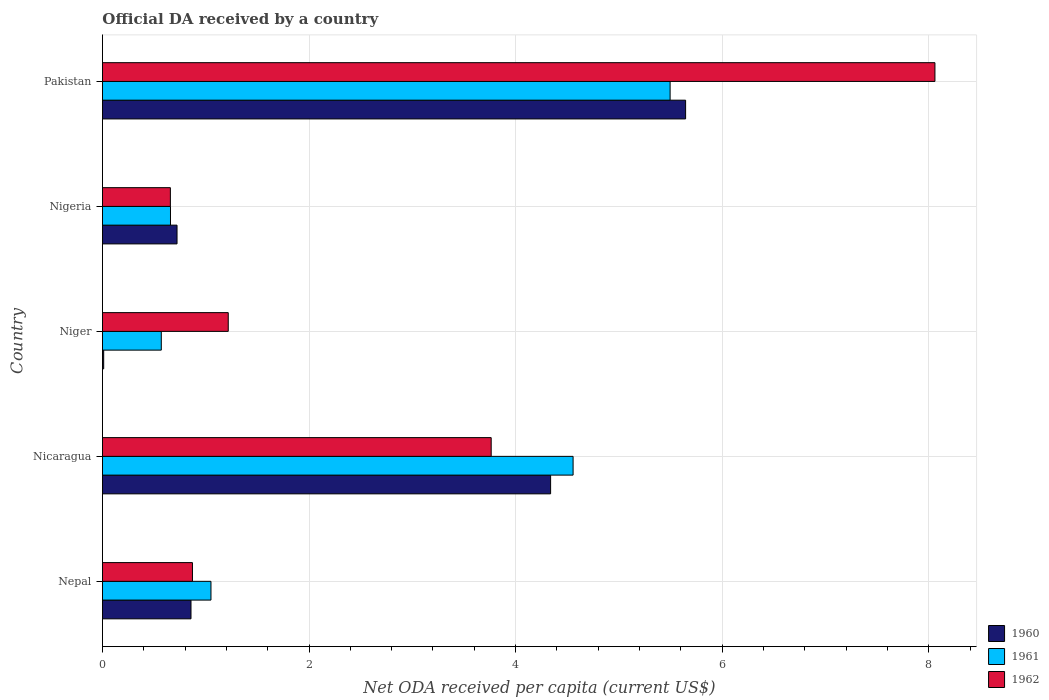How many different coloured bars are there?
Make the answer very short. 3. How many groups of bars are there?
Give a very brief answer. 5. How many bars are there on the 2nd tick from the top?
Your response must be concise. 3. What is the ODA received in in 1960 in Nicaragua?
Offer a terse response. 4.34. Across all countries, what is the maximum ODA received in in 1962?
Make the answer very short. 8.06. Across all countries, what is the minimum ODA received in in 1960?
Your answer should be very brief. 0.01. In which country was the ODA received in in 1961 minimum?
Your answer should be compact. Niger. What is the total ODA received in in 1960 in the graph?
Give a very brief answer. 11.58. What is the difference between the ODA received in in 1960 in Nepal and that in Pakistan?
Offer a terse response. -4.79. What is the difference between the ODA received in in 1962 in Nepal and the ODA received in in 1961 in Niger?
Offer a terse response. 0.3. What is the average ODA received in in 1960 per country?
Offer a terse response. 2.32. What is the difference between the ODA received in in 1962 and ODA received in in 1961 in Pakistan?
Provide a succinct answer. 2.56. What is the ratio of the ODA received in in 1961 in Nepal to that in Pakistan?
Provide a short and direct response. 0.19. Is the difference between the ODA received in in 1962 in Nicaragua and Niger greater than the difference between the ODA received in in 1961 in Nicaragua and Niger?
Provide a short and direct response. No. What is the difference between the highest and the second highest ODA received in in 1962?
Ensure brevity in your answer.  4.3. What is the difference between the highest and the lowest ODA received in in 1960?
Provide a short and direct response. 5.63. Is the sum of the ODA received in in 1960 in Niger and Nigeria greater than the maximum ODA received in in 1962 across all countries?
Give a very brief answer. No. What does the 1st bar from the bottom in Nigeria represents?
Make the answer very short. 1960. Is it the case that in every country, the sum of the ODA received in in 1961 and ODA received in in 1960 is greater than the ODA received in in 1962?
Keep it short and to the point. No. Are all the bars in the graph horizontal?
Provide a succinct answer. Yes. What is the difference between two consecutive major ticks on the X-axis?
Keep it short and to the point. 2. Are the values on the major ticks of X-axis written in scientific E-notation?
Keep it short and to the point. No. Where does the legend appear in the graph?
Make the answer very short. Bottom right. How are the legend labels stacked?
Your answer should be compact. Vertical. What is the title of the graph?
Keep it short and to the point. Official DA received by a country. What is the label or title of the X-axis?
Your answer should be very brief. Net ODA received per capita (current US$). What is the label or title of the Y-axis?
Offer a very short reply. Country. What is the Net ODA received per capita (current US$) in 1960 in Nepal?
Keep it short and to the point. 0.86. What is the Net ODA received per capita (current US$) of 1961 in Nepal?
Make the answer very short. 1.05. What is the Net ODA received per capita (current US$) of 1962 in Nepal?
Give a very brief answer. 0.87. What is the Net ODA received per capita (current US$) in 1960 in Nicaragua?
Your response must be concise. 4.34. What is the Net ODA received per capita (current US$) of 1961 in Nicaragua?
Your answer should be compact. 4.56. What is the Net ODA received per capita (current US$) in 1962 in Nicaragua?
Your answer should be very brief. 3.76. What is the Net ODA received per capita (current US$) in 1960 in Niger?
Offer a very short reply. 0.01. What is the Net ODA received per capita (current US$) of 1961 in Niger?
Offer a very short reply. 0.57. What is the Net ODA received per capita (current US$) of 1962 in Niger?
Offer a terse response. 1.22. What is the Net ODA received per capita (current US$) of 1960 in Nigeria?
Your answer should be compact. 0.72. What is the Net ODA received per capita (current US$) of 1961 in Nigeria?
Your answer should be very brief. 0.66. What is the Net ODA received per capita (current US$) in 1962 in Nigeria?
Give a very brief answer. 0.66. What is the Net ODA received per capita (current US$) in 1960 in Pakistan?
Keep it short and to the point. 5.65. What is the Net ODA received per capita (current US$) of 1961 in Pakistan?
Provide a short and direct response. 5.5. What is the Net ODA received per capita (current US$) in 1962 in Pakistan?
Ensure brevity in your answer.  8.06. Across all countries, what is the maximum Net ODA received per capita (current US$) of 1960?
Offer a terse response. 5.65. Across all countries, what is the maximum Net ODA received per capita (current US$) of 1961?
Your answer should be very brief. 5.5. Across all countries, what is the maximum Net ODA received per capita (current US$) of 1962?
Keep it short and to the point. 8.06. Across all countries, what is the minimum Net ODA received per capita (current US$) in 1960?
Provide a short and direct response. 0.01. Across all countries, what is the minimum Net ODA received per capita (current US$) in 1961?
Provide a succinct answer. 0.57. Across all countries, what is the minimum Net ODA received per capita (current US$) in 1962?
Give a very brief answer. 0.66. What is the total Net ODA received per capita (current US$) of 1960 in the graph?
Ensure brevity in your answer.  11.58. What is the total Net ODA received per capita (current US$) of 1961 in the graph?
Make the answer very short. 12.33. What is the total Net ODA received per capita (current US$) in 1962 in the graph?
Offer a terse response. 14.57. What is the difference between the Net ODA received per capita (current US$) of 1960 in Nepal and that in Nicaragua?
Your response must be concise. -3.48. What is the difference between the Net ODA received per capita (current US$) of 1961 in Nepal and that in Nicaragua?
Provide a succinct answer. -3.51. What is the difference between the Net ODA received per capita (current US$) of 1962 in Nepal and that in Nicaragua?
Offer a very short reply. -2.89. What is the difference between the Net ODA received per capita (current US$) of 1960 in Nepal and that in Niger?
Offer a terse response. 0.85. What is the difference between the Net ODA received per capita (current US$) in 1961 in Nepal and that in Niger?
Ensure brevity in your answer.  0.48. What is the difference between the Net ODA received per capita (current US$) of 1962 in Nepal and that in Niger?
Offer a very short reply. -0.35. What is the difference between the Net ODA received per capita (current US$) in 1960 in Nepal and that in Nigeria?
Give a very brief answer. 0.14. What is the difference between the Net ODA received per capita (current US$) in 1961 in Nepal and that in Nigeria?
Provide a succinct answer. 0.39. What is the difference between the Net ODA received per capita (current US$) of 1962 in Nepal and that in Nigeria?
Offer a very short reply. 0.21. What is the difference between the Net ODA received per capita (current US$) in 1960 in Nepal and that in Pakistan?
Keep it short and to the point. -4.79. What is the difference between the Net ODA received per capita (current US$) of 1961 in Nepal and that in Pakistan?
Offer a terse response. -4.45. What is the difference between the Net ODA received per capita (current US$) of 1962 in Nepal and that in Pakistan?
Provide a succinct answer. -7.19. What is the difference between the Net ODA received per capita (current US$) of 1960 in Nicaragua and that in Niger?
Offer a very short reply. 4.33. What is the difference between the Net ODA received per capita (current US$) in 1961 in Nicaragua and that in Niger?
Keep it short and to the point. 3.99. What is the difference between the Net ODA received per capita (current US$) of 1962 in Nicaragua and that in Niger?
Your answer should be compact. 2.55. What is the difference between the Net ODA received per capita (current US$) in 1960 in Nicaragua and that in Nigeria?
Your answer should be very brief. 3.62. What is the difference between the Net ODA received per capita (current US$) in 1961 in Nicaragua and that in Nigeria?
Keep it short and to the point. 3.9. What is the difference between the Net ODA received per capita (current US$) of 1962 in Nicaragua and that in Nigeria?
Provide a succinct answer. 3.11. What is the difference between the Net ODA received per capita (current US$) in 1960 in Nicaragua and that in Pakistan?
Make the answer very short. -1.31. What is the difference between the Net ODA received per capita (current US$) in 1961 in Nicaragua and that in Pakistan?
Make the answer very short. -0.94. What is the difference between the Net ODA received per capita (current US$) of 1962 in Nicaragua and that in Pakistan?
Ensure brevity in your answer.  -4.3. What is the difference between the Net ODA received per capita (current US$) in 1960 in Niger and that in Nigeria?
Provide a succinct answer. -0.71. What is the difference between the Net ODA received per capita (current US$) of 1961 in Niger and that in Nigeria?
Give a very brief answer. -0.09. What is the difference between the Net ODA received per capita (current US$) in 1962 in Niger and that in Nigeria?
Ensure brevity in your answer.  0.56. What is the difference between the Net ODA received per capita (current US$) in 1960 in Niger and that in Pakistan?
Give a very brief answer. -5.63. What is the difference between the Net ODA received per capita (current US$) of 1961 in Niger and that in Pakistan?
Keep it short and to the point. -4.93. What is the difference between the Net ODA received per capita (current US$) of 1962 in Niger and that in Pakistan?
Provide a succinct answer. -6.84. What is the difference between the Net ODA received per capita (current US$) in 1960 in Nigeria and that in Pakistan?
Keep it short and to the point. -4.92. What is the difference between the Net ODA received per capita (current US$) of 1961 in Nigeria and that in Pakistan?
Ensure brevity in your answer.  -4.84. What is the difference between the Net ODA received per capita (current US$) in 1962 in Nigeria and that in Pakistan?
Give a very brief answer. -7.4. What is the difference between the Net ODA received per capita (current US$) of 1960 in Nepal and the Net ODA received per capita (current US$) of 1961 in Nicaragua?
Give a very brief answer. -3.7. What is the difference between the Net ODA received per capita (current US$) of 1960 in Nepal and the Net ODA received per capita (current US$) of 1962 in Nicaragua?
Provide a succinct answer. -2.91. What is the difference between the Net ODA received per capita (current US$) in 1961 in Nepal and the Net ODA received per capita (current US$) in 1962 in Nicaragua?
Provide a succinct answer. -2.71. What is the difference between the Net ODA received per capita (current US$) in 1960 in Nepal and the Net ODA received per capita (current US$) in 1961 in Niger?
Keep it short and to the point. 0.29. What is the difference between the Net ODA received per capita (current US$) of 1960 in Nepal and the Net ODA received per capita (current US$) of 1962 in Niger?
Your answer should be compact. -0.36. What is the difference between the Net ODA received per capita (current US$) in 1961 in Nepal and the Net ODA received per capita (current US$) in 1962 in Niger?
Give a very brief answer. -0.17. What is the difference between the Net ODA received per capita (current US$) of 1960 in Nepal and the Net ODA received per capita (current US$) of 1961 in Nigeria?
Provide a short and direct response. 0.2. What is the difference between the Net ODA received per capita (current US$) in 1960 in Nepal and the Net ODA received per capita (current US$) in 1962 in Nigeria?
Provide a succinct answer. 0.2. What is the difference between the Net ODA received per capita (current US$) of 1961 in Nepal and the Net ODA received per capita (current US$) of 1962 in Nigeria?
Offer a terse response. 0.39. What is the difference between the Net ODA received per capita (current US$) in 1960 in Nepal and the Net ODA received per capita (current US$) in 1961 in Pakistan?
Ensure brevity in your answer.  -4.64. What is the difference between the Net ODA received per capita (current US$) in 1960 in Nepal and the Net ODA received per capita (current US$) in 1962 in Pakistan?
Your answer should be very brief. -7.2. What is the difference between the Net ODA received per capita (current US$) of 1961 in Nepal and the Net ODA received per capita (current US$) of 1962 in Pakistan?
Offer a very short reply. -7.01. What is the difference between the Net ODA received per capita (current US$) in 1960 in Nicaragua and the Net ODA received per capita (current US$) in 1961 in Niger?
Keep it short and to the point. 3.77. What is the difference between the Net ODA received per capita (current US$) in 1960 in Nicaragua and the Net ODA received per capita (current US$) in 1962 in Niger?
Ensure brevity in your answer.  3.12. What is the difference between the Net ODA received per capita (current US$) of 1961 in Nicaragua and the Net ODA received per capita (current US$) of 1962 in Niger?
Keep it short and to the point. 3.34. What is the difference between the Net ODA received per capita (current US$) of 1960 in Nicaragua and the Net ODA received per capita (current US$) of 1961 in Nigeria?
Make the answer very short. 3.68. What is the difference between the Net ODA received per capita (current US$) of 1960 in Nicaragua and the Net ODA received per capita (current US$) of 1962 in Nigeria?
Ensure brevity in your answer.  3.68. What is the difference between the Net ODA received per capita (current US$) of 1961 in Nicaragua and the Net ODA received per capita (current US$) of 1962 in Nigeria?
Provide a short and direct response. 3.9. What is the difference between the Net ODA received per capita (current US$) in 1960 in Nicaragua and the Net ODA received per capita (current US$) in 1961 in Pakistan?
Ensure brevity in your answer.  -1.16. What is the difference between the Net ODA received per capita (current US$) in 1960 in Nicaragua and the Net ODA received per capita (current US$) in 1962 in Pakistan?
Your answer should be compact. -3.72. What is the difference between the Net ODA received per capita (current US$) in 1961 in Nicaragua and the Net ODA received per capita (current US$) in 1962 in Pakistan?
Provide a short and direct response. -3.5. What is the difference between the Net ODA received per capita (current US$) in 1960 in Niger and the Net ODA received per capita (current US$) in 1961 in Nigeria?
Keep it short and to the point. -0.65. What is the difference between the Net ODA received per capita (current US$) in 1960 in Niger and the Net ODA received per capita (current US$) in 1962 in Nigeria?
Ensure brevity in your answer.  -0.65. What is the difference between the Net ODA received per capita (current US$) in 1961 in Niger and the Net ODA received per capita (current US$) in 1962 in Nigeria?
Provide a succinct answer. -0.09. What is the difference between the Net ODA received per capita (current US$) in 1960 in Niger and the Net ODA received per capita (current US$) in 1961 in Pakistan?
Ensure brevity in your answer.  -5.48. What is the difference between the Net ODA received per capita (current US$) in 1960 in Niger and the Net ODA received per capita (current US$) in 1962 in Pakistan?
Your answer should be very brief. -8.05. What is the difference between the Net ODA received per capita (current US$) of 1961 in Niger and the Net ODA received per capita (current US$) of 1962 in Pakistan?
Your answer should be very brief. -7.49. What is the difference between the Net ODA received per capita (current US$) of 1960 in Nigeria and the Net ODA received per capita (current US$) of 1961 in Pakistan?
Your answer should be compact. -4.77. What is the difference between the Net ODA received per capita (current US$) of 1960 in Nigeria and the Net ODA received per capita (current US$) of 1962 in Pakistan?
Your answer should be very brief. -7.34. What is the difference between the Net ODA received per capita (current US$) of 1961 in Nigeria and the Net ODA received per capita (current US$) of 1962 in Pakistan?
Give a very brief answer. -7.4. What is the average Net ODA received per capita (current US$) of 1960 per country?
Provide a succinct answer. 2.32. What is the average Net ODA received per capita (current US$) in 1961 per country?
Your response must be concise. 2.47. What is the average Net ODA received per capita (current US$) in 1962 per country?
Your answer should be compact. 2.91. What is the difference between the Net ODA received per capita (current US$) in 1960 and Net ODA received per capita (current US$) in 1961 in Nepal?
Offer a very short reply. -0.19. What is the difference between the Net ODA received per capita (current US$) of 1960 and Net ODA received per capita (current US$) of 1962 in Nepal?
Make the answer very short. -0.01. What is the difference between the Net ODA received per capita (current US$) in 1961 and Net ODA received per capita (current US$) in 1962 in Nepal?
Offer a very short reply. 0.18. What is the difference between the Net ODA received per capita (current US$) of 1960 and Net ODA received per capita (current US$) of 1961 in Nicaragua?
Offer a terse response. -0.22. What is the difference between the Net ODA received per capita (current US$) of 1960 and Net ODA received per capita (current US$) of 1962 in Nicaragua?
Keep it short and to the point. 0.58. What is the difference between the Net ODA received per capita (current US$) in 1961 and Net ODA received per capita (current US$) in 1962 in Nicaragua?
Ensure brevity in your answer.  0.79. What is the difference between the Net ODA received per capita (current US$) of 1960 and Net ODA received per capita (current US$) of 1961 in Niger?
Provide a short and direct response. -0.56. What is the difference between the Net ODA received per capita (current US$) of 1960 and Net ODA received per capita (current US$) of 1962 in Niger?
Keep it short and to the point. -1.21. What is the difference between the Net ODA received per capita (current US$) of 1961 and Net ODA received per capita (current US$) of 1962 in Niger?
Your answer should be very brief. -0.65. What is the difference between the Net ODA received per capita (current US$) of 1960 and Net ODA received per capita (current US$) of 1961 in Nigeria?
Provide a succinct answer. 0.06. What is the difference between the Net ODA received per capita (current US$) of 1960 and Net ODA received per capita (current US$) of 1962 in Nigeria?
Offer a terse response. 0.06. What is the difference between the Net ODA received per capita (current US$) in 1961 and Net ODA received per capita (current US$) in 1962 in Nigeria?
Your response must be concise. 0. What is the difference between the Net ODA received per capita (current US$) of 1960 and Net ODA received per capita (current US$) of 1961 in Pakistan?
Provide a short and direct response. 0.15. What is the difference between the Net ODA received per capita (current US$) of 1960 and Net ODA received per capita (current US$) of 1962 in Pakistan?
Keep it short and to the point. -2.41. What is the difference between the Net ODA received per capita (current US$) of 1961 and Net ODA received per capita (current US$) of 1962 in Pakistan?
Give a very brief answer. -2.56. What is the ratio of the Net ODA received per capita (current US$) in 1960 in Nepal to that in Nicaragua?
Give a very brief answer. 0.2. What is the ratio of the Net ODA received per capita (current US$) in 1961 in Nepal to that in Nicaragua?
Keep it short and to the point. 0.23. What is the ratio of the Net ODA received per capita (current US$) in 1962 in Nepal to that in Nicaragua?
Make the answer very short. 0.23. What is the ratio of the Net ODA received per capita (current US$) in 1960 in Nepal to that in Niger?
Your answer should be compact. 72.75. What is the ratio of the Net ODA received per capita (current US$) in 1961 in Nepal to that in Niger?
Ensure brevity in your answer.  1.84. What is the ratio of the Net ODA received per capita (current US$) of 1962 in Nepal to that in Niger?
Offer a terse response. 0.72. What is the ratio of the Net ODA received per capita (current US$) of 1960 in Nepal to that in Nigeria?
Provide a short and direct response. 1.19. What is the ratio of the Net ODA received per capita (current US$) in 1961 in Nepal to that in Nigeria?
Ensure brevity in your answer.  1.59. What is the ratio of the Net ODA received per capita (current US$) of 1962 in Nepal to that in Nigeria?
Your answer should be compact. 1.32. What is the ratio of the Net ODA received per capita (current US$) of 1960 in Nepal to that in Pakistan?
Ensure brevity in your answer.  0.15. What is the ratio of the Net ODA received per capita (current US$) of 1961 in Nepal to that in Pakistan?
Your answer should be compact. 0.19. What is the ratio of the Net ODA received per capita (current US$) in 1962 in Nepal to that in Pakistan?
Keep it short and to the point. 0.11. What is the ratio of the Net ODA received per capita (current US$) of 1960 in Nicaragua to that in Niger?
Give a very brief answer. 368.28. What is the ratio of the Net ODA received per capita (current US$) of 1961 in Nicaragua to that in Niger?
Offer a very short reply. 8. What is the ratio of the Net ODA received per capita (current US$) in 1962 in Nicaragua to that in Niger?
Your answer should be compact. 3.09. What is the ratio of the Net ODA received per capita (current US$) in 1960 in Nicaragua to that in Nigeria?
Give a very brief answer. 6.01. What is the ratio of the Net ODA received per capita (current US$) in 1961 in Nicaragua to that in Nigeria?
Offer a very short reply. 6.92. What is the ratio of the Net ODA received per capita (current US$) of 1962 in Nicaragua to that in Nigeria?
Keep it short and to the point. 5.72. What is the ratio of the Net ODA received per capita (current US$) of 1960 in Nicaragua to that in Pakistan?
Your answer should be compact. 0.77. What is the ratio of the Net ODA received per capita (current US$) of 1961 in Nicaragua to that in Pakistan?
Keep it short and to the point. 0.83. What is the ratio of the Net ODA received per capita (current US$) in 1962 in Nicaragua to that in Pakistan?
Provide a short and direct response. 0.47. What is the ratio of the Net ODA received per capita (current US$) in 1960 in Niger to that in Nigeria?
Make the answer very short. 0.02. What is the ratio of the Net ODA received per capita (current US$) in 1961 in Niger to that in Nigeria?
Provide a short and direct response. 0.86. What is the ratio of the Net ODA received per capita (current US$) of 1962 in Niger to that in Nigeria?
Make the answer very short. 1.85. What is the ratio of the Net ODA received per capita (current US$) in 1960 in Niger to that in Pakistan?
Provide a short and direct response. 0. What is the ratio of the Net ODA received per capita (current US$) of 1961 in Niger to that in Pakistan?
Offer a very short reply. 0.1. What is the ratio of the Net ODA received per capita (current US$) of 1962 in Niger to that in Pakistan?
Give a very brief answer. 0.15. What is the ratio of the Net ODA received per capita (current US$) in 1960 in Nigeria to that in Pakistan?
Provide a short and direct response. 0.13. What is the ratio of the Net ODA received per capita (current US$) of 1961 in Nigeria to that in Pakistan?
Give a very brief answer. 0.12. What is the ratio of the Net ODA received per capita (current US$) in 1962 in Nigeria to that in Pakistan?
Your answer should be very brief. 0.08. What is the difference between the highest and the second highest Net ODA received per capita (current US$) in 1960?
Ensure brevity in your answer.  1.31. What is the difference between the highest and the second highest Net ODA received per capita (current US$) of 1961?
Your answer should be compact. 0.94. What is the difference between the highest and the second highest Net ODA received per capita (current US$) in 1962?
Your answer should be compact. 4.3. What is the difference between the highest and the lowest Net ODA received per capita (current US$) in 1960?
Provide a succinct answer. 5.63. What is the difference between the highest and the lowest Net ODA received per capita (current US$) of 1961?
Your response must be concise. 4.93. What is the difference between the highest and the lowest Net ODA received per capita (current US$) in 1962?
Your response must be concise. 7.4. 